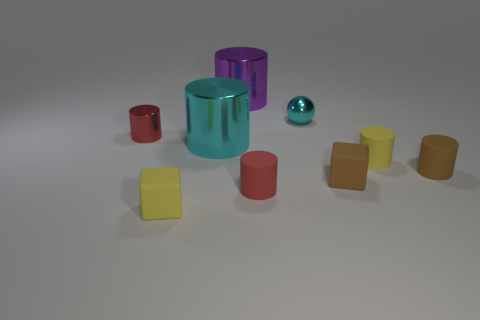The cyan object that is the same shape as the big purple thing is what size?
Offer a terse response. Large. There is a metallic object that is behind the small red shiny object and on the left side of the tiny cyan shiny ball; what size is it?
Provide a succinct answer. Large. There is a brown block; is its size the same as the cyan thing that is in front of the tiny red metallic cylinder?
Provide a succinct answer. No. Is the number of gray metal cylinders less than the number of small objects?
Your response must be concise. Yes. Is the cyan cylinder made of the same material as the tiny cyan object?
Provide a succinct answer. Yes. How many other things are the same size as the yellow rubber cylinder?
Keep it short and to the point. 6. What is the color of the small rubber cube that is on the left side of the large metallic thing that is behind the red metal cylinder?
Ensure brevity in your answer.  Yellow. What number of other objects are there of the same shape as the large purple metallic object?
Provide a succinct answer. 5. Is there a red cylinder that has the same material as the large cyan cylinder?
Give a very brief answer. Yes. There is a cyan thing that is the same size as the purple cylinder; what is it made of?
Offer a terse response. Metal. 